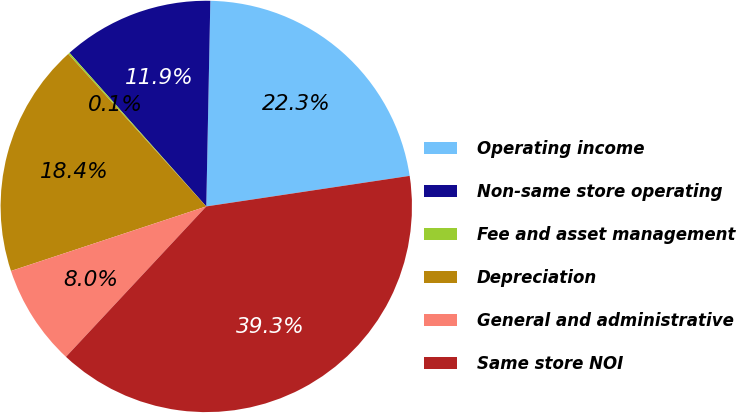Convert chart. <chart><loc_0><loc_0><loc_500><loc_500><pie_chart><fcel>Operating income<fcel>Non-same store operating<fcel>Fee and asset management<fcel>Depreciation<fcel>General and administrative<fcel>Same store NOI<nl><fcel>22.31%<fcel>11.89%<fcel>0.13%<fcel>18.37%<fcel>7.97%<fcel>39.32%<nl></chart> 